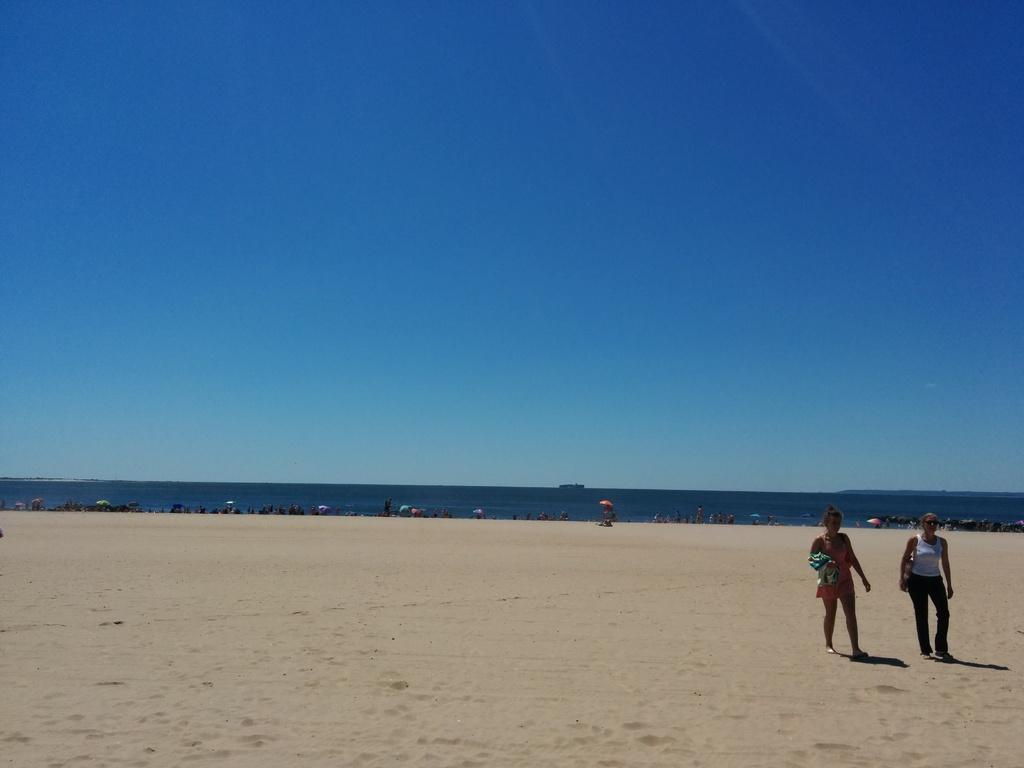How would you summarize this image in a sentence or two? There are two women walking on the sand surface of the ground. In the background, there are persons near an ocean and there is blue sky. 